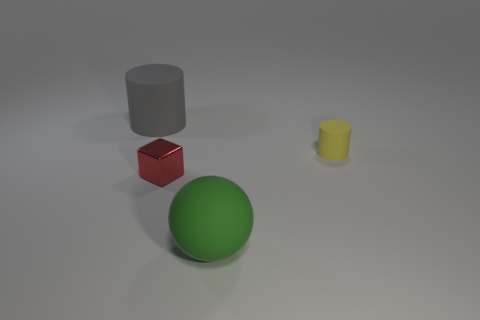The large green object that is made of the same material as the small cylinder is what shape?
Make the answer very short. Sphere. Do the big object that is in front of the gray cylinder and the big rubber thing that is behind the large green matte sphere have the same shape?
Keep it short and to the point. No. Is the number of big spheres behind the tiny yellow thing less than the number of tiny yellow cylinders that are on the left side of the big gray rubber cylinder?
Ensure brevity in your answer.  No. How many other metal blocks have the same size as the red cube?
Keep it short and to the point. 0. Is the material of the thing to the right of the big matte sphere the same as the sphere?
Ensure brevity in your answer.  Yes. Is there a small yellow matte cylinder?
Make the answer very short. Yes. The green object that is made of the same material as the tiny yellow cylinder is what size?
Make the answer very short. Large. Is there a tiny matte thing of the same color as the large rubber sphere?
Provide a succinct answer. No. Does the rubber cylinder on the left side of the small yellow cylinder have the same color as the object that is on the right side of the big green rubber object?
Ensure brevity in your answer.  No. Is there another tiny object made of the same material as the green object?
Keep it short and to the point. Yes. 